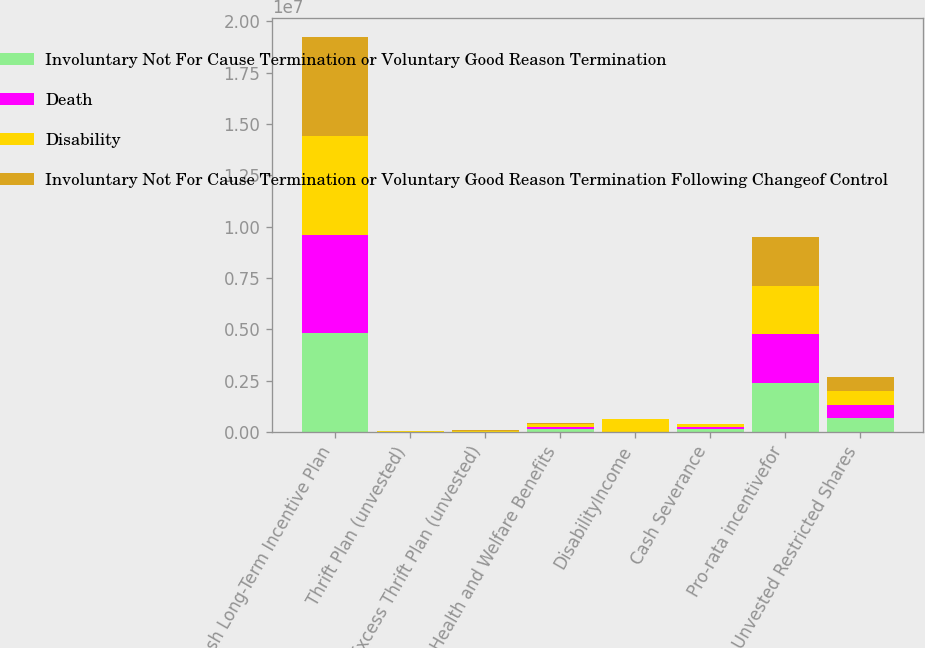Convert chart. <chart><loc_0><loc_0><loc_500><loc_500><stacked_bar_chart><ecel><fcel>Cash Long-Term Incentive Plan<fcel>Thrift Plan (unvested)<fcel>Excess Thrift Plan (unvested)<fcel>Health and Welfare Benefits<fcel>DisabilityIncome<fcel>Cash Severance<fcel>Pro-rata incentivefor<fcel>Unvested Restricted Shares<nl><fcel>Involuntary Not For Cause Termination or Voluntary Good Reason Termination<fcel>4.80513e+06<fcel>0<fcel>0<fcel>120891<fcel>0<fcel>120891<fcel>2.375e+06<fcel>662705<nl><fcel>Death<fcel>4.80513e+06<fcel>0<fcel>0<fcel>120891<fcel>0<fcel>120891<fcel>2.375e+06<fcel>662705<nl><fcel>Disability<fcel>4.80513e+06<fcel>18180<fcel>33481<fcel>120891<fcel>623240<fcel>120891<fcel>2.375e+06<fcel>662705<nl><fcel>Involuntary Not For Cause Termination or Voluntary Good Reason Termination Following Changeof Control<fcel>4.80513e+06<fcel>18180<fcel>33481<fcel>60945<fcel>0<fcel>0<fcel>2.375e+06<fcel>662705<nl></chart> 